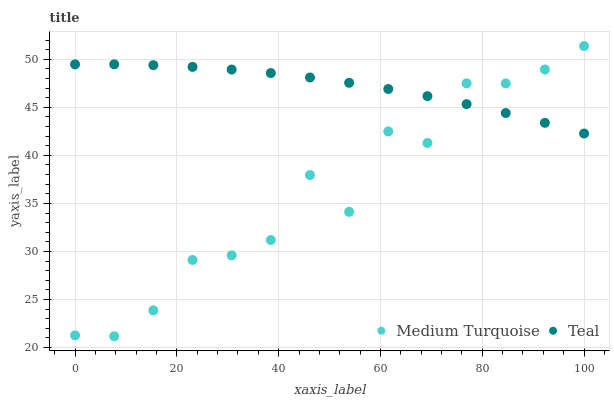Does Medium Turquoise have the minimum area under the curve?
Answer yes or no. Yes. Does Teal have the maximum area under the curve?
Answer yes or no. Yes. Does Medium Turquoise have the maximum area under the curve?
Answer yes or no. No. Is Teal the smoothest?
Answer yes or no. Yes. Is Medium Turquoise the roughest?
Answer yes or no. Yes. Is Medium Turquoise the smoothest?
Answer yes or no. No. Does Medium Turquoise have the lowest value?
Answer yes or no. Yes. Does Medium Turquoise have the highest value?
Answer yes or no. Yes. Does Medium Turquoise intersect Teal?
Answer yes or no. Yes. Is Medium Turquoise less than Teal?
Answer yes or no. No. Is Medium Turquoise greater than Teal?
Answer yes or no. No. 